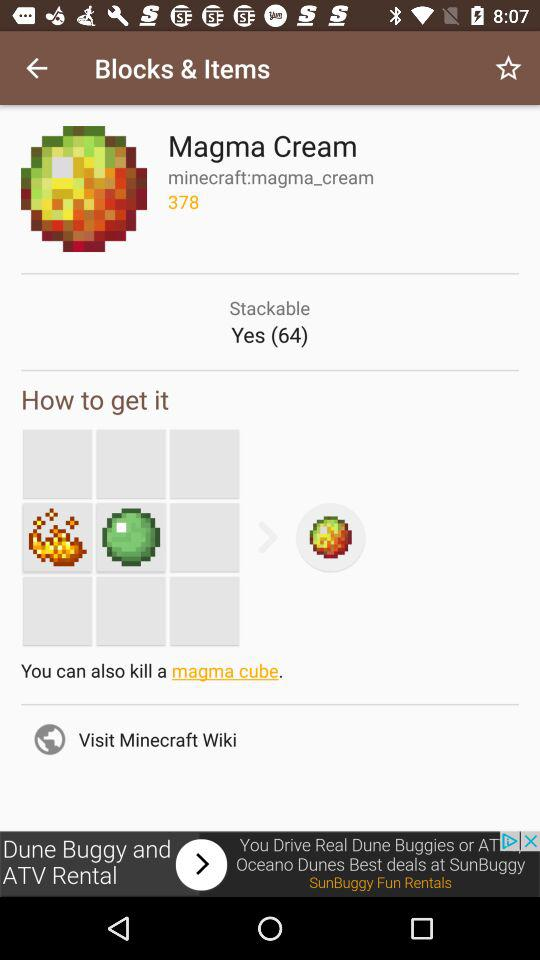How many ways are there to obtain magma cream?
Answer the question using a single word or phrase. 3 